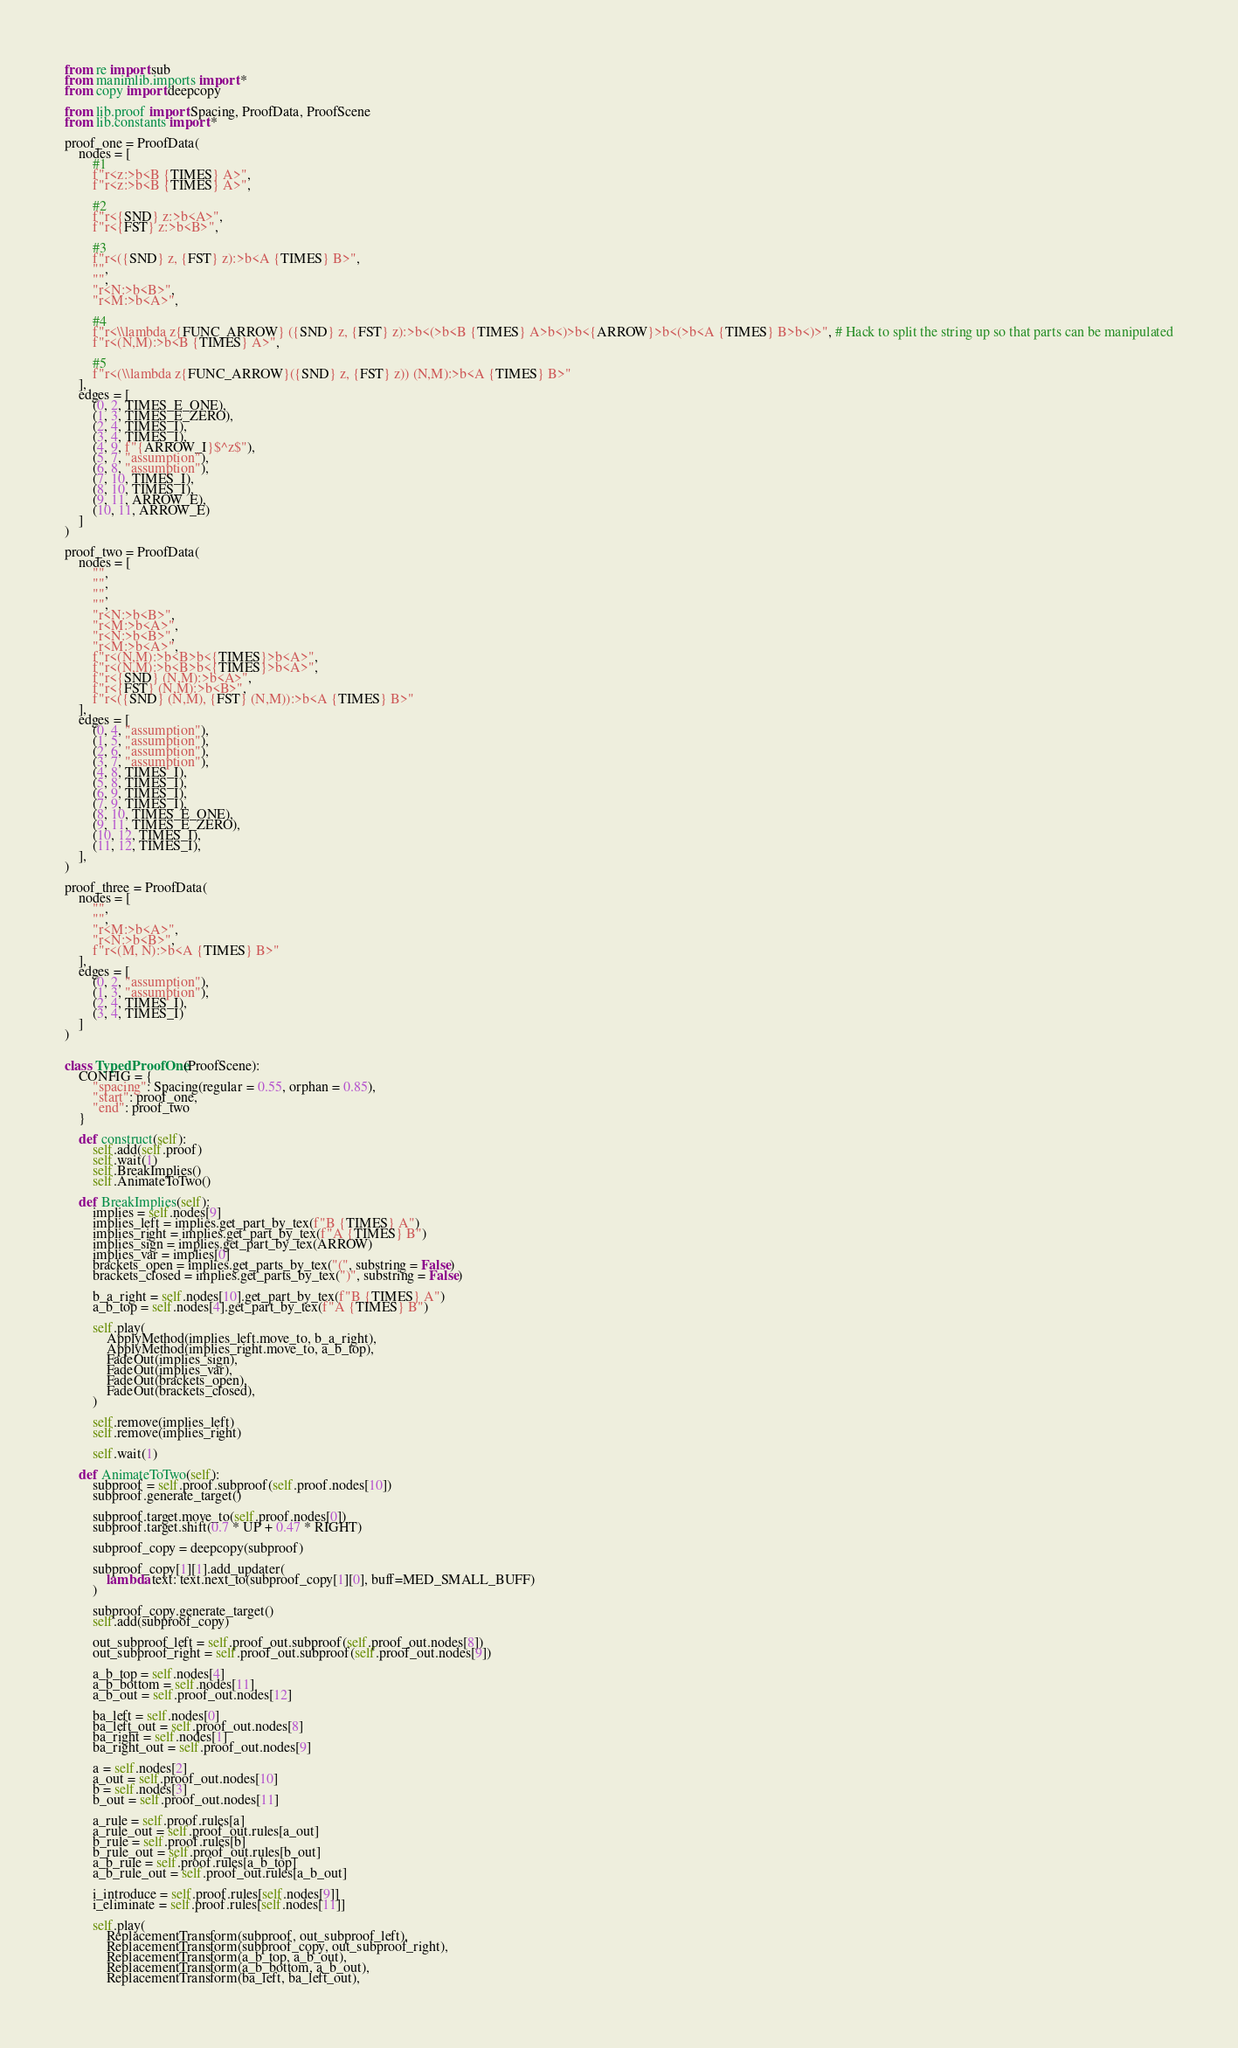Convert code to text. <code><loc_0><loc_0><loc_500><loc_500><_Python_>from re import sub
from manimlib.imports import *
from copy import deepcopy

from lib.proof import Spacing, ProofData, ProofScene
from lib.constants import *

proof_one = ProofData(
    nodes = [
        #1
        f"r<z:>b<B {TIMES} A>",
        f"r<z:>b<B {TIMES} A>",
        
        #2
        f"r<{SND} z:>b<A>",
        f"r<{FST} z:>b<B>",
        
        #3 
        f"r<({SND} z, {FST} z):>b<A {TIMES} B>",
        "",
        "",
        "r<N:>b<B>",
        "r<M:>b<A>",
        
        #4
        f"r<\\lambda z{FUNC_ARROW} ({SND} z, {FST} z):>b<(>b<B {TIMES} A>b<)>b<{ARROW}>b<(>b<A {TIMES} B>b<)>", # Hack to split the string up so that parts can be manipulated
        f"r<(N,M):>b<B {TIMES} A>",
        
        #5
        f"r<(\\lambda z{FUNC_ARROW}({SND} z, {FST} z)) (N,M):>b<A {TIMES} B>"
    ],
    edges = [
        (0, 2, TIMES_E_ONE),
        (1, 3, TIMES_E_ZERO),
        (2, 4, TIMES_I),
        (3, 4, TIMES_I),
        (4, 9, f"{ARROW_I}$^z$"),
        (5, 7, "assumption"),
        (6, 8, "assumption"),
        (7, 10, TIMES_I),
        (8, 10, TIMES_I),
        (9, 11, ARROW_E),
        (10, 11, ARROW_E)
    ]
)

proof_two = ProofData(
    nodes = [
        "",
        "",
        "",
        "",
        "r<N:>b<B>",
        "r<M:>b<A>",
        "r<N:>b<B>",
        "r<M:>b<A>",
        f"r<(N,M):>b<B>b<{TIMES}>b<A>",
        f"r<(N,M):>b<B>b<{TIMES}>b<A>",
        f"r<{SND} (N,M):>b<A>",
        f"r<{FST} (N,M):>b<B>",
        f"r<({SND} (N,M), {FST} (N,M)):>b<A {TIMES} B>"
    ],
    edges = [
        (0, 4, "assumption"),
        (1, 5, "assumption"),
        (2, 6, "assumption"),
        (3, 7, "assumption"),
        (4, 8, TIMES_I),
        (5, 8, TIMES_I),
        (6, 9, TIMES_I),
        (7, 9, TIMES_I),
        (8, 10, TIMES_E_ONE),
        (9, 11, TIMES_E_ZERO),
        (10, 12, TIMES_I),
        (11, 12, TIMES_I),
    ],
)

proof_three = ProofData(
    nodes = [
        "",
        "",
        "r<M:>b<A>",
        "r<N:>b<B>",
        f"r<(M, N):>b<A {TIMES} B>"
    ],
    edges = [
        (0, 2, "assumption"),
        (1, 3, "assumption"),
        (2, 4, TIMES_I),
        (3, 4, TIMES_I)
    ]
)


class TypedProofOne(ProofScene):
    CONFIG = {
        "spacing": Spacing(regular = 0.55, orphan = 0.85),
        "start": proof_one,
        "end": proof_two
    }

    def construct(self):
        self.add(self.proof)
        self.wait(1)
        self.BreakImplies()
        self.AnimateToTwo()
    
    def BreakImplies(self):
        implies = self.nodes[9]
        implies_left = implies.get_part_by_tex(f"B {TIMES} A")
        implies_right = implies.get_part_by_tex(f"A {TIMES} B")
        implies_sign = implies.get_part_by_tex(ARROW)
        implies_var = implies[0]
        brackets_open = implies.get_parts_by_tex("(", substring = False)
        brackets_closed = implies.get_parts_by_tex(")", substring = False)

        b_a_right = self.nodes[10].get_part_by_tex(f"B {TIMES} A")
        a_b_top = self.nodes[4].get_part_by_tex(f"A {TIMES} B")

        self.play(
            ApplyMethod(implies_left.move_to, b_a_right),
            ApplyMethod(implies_right.move_to, a_b_top),
            FadeOut(implies_sign),
            FadeOut(implies_var),
            FadeOut(brackets_open),
            FadeOut(brackets_closed),
        )

        self.remove(implies_left)
        self.remove(implies_right)

        self.wait(1)

    def AnimateToTwo(self):
        subproof = self.proof.subproof(self.proof.nodes[10])
        subproof.generate_target()

        subproof.target.move_to(self.proof.nodes[0])
        subproof.target.shift(0.7 * UP + 0.47 * RIGHT)
        
        subproof_copy = deepcopy(subproof)

        subproof_copy[1][1].add_updater(
            lambda text: text.next_to(subproof_copy[1][0], buff=MED_SMALL_BUFF)
        )

        subproof_copy.generate_target()
        self.add(subproof_copy)

        out_subproof_left = self.proof_out.subproof(self.proof_out.nodes[8])
        out_subproof_right = self.proof_out.subproof(self.proof_out.nodes[9])

        a_b_top = self.nodes[4]
        a_b_bottom = self.nodes[11]
        a_b_out = self.proof_out.nodes[12]

        ba_left = self.nodes[0]
        ba_left_out = self.proof_out.nodes[8]
        ba_right = self.nodes[1]
        ba_right_out = self.proof_out.nodes[9]

        a = self.nodes[2]
        a_out = self.proof_out.nodes[10]
        b = self.nodes[3]
        b_out = self.proof_out.nodes[11]

        a_rule = self.proof.rules[a]
        a_rule_out = self.proof_out.rules[a_out]
        b_rule = self.proof.rules[b]
        b_rule_out = self.proof_out.rules[b_out]
        a_b_rule = self.proof.rules[a_b_top]
        a_b_rule_out = self.proof_out.rules[a_b_out]

        i_introduce = self.proof.rules[self.nodes[9]]
        i_eliminate = self.proof.rules[self.nodes[11]]

        self.play(
            ReplacementTransform(subproof, out_subproof_left),
            ReplacementTransform(subproof_copy, out_subproof_right),
            ReplacementTransform(a_b_top, a_b_out),
            ReplacementTransform(a_b_bottom, a_b_out),
            ReplacementTransform(ba_left, ba_left_out),</code> 